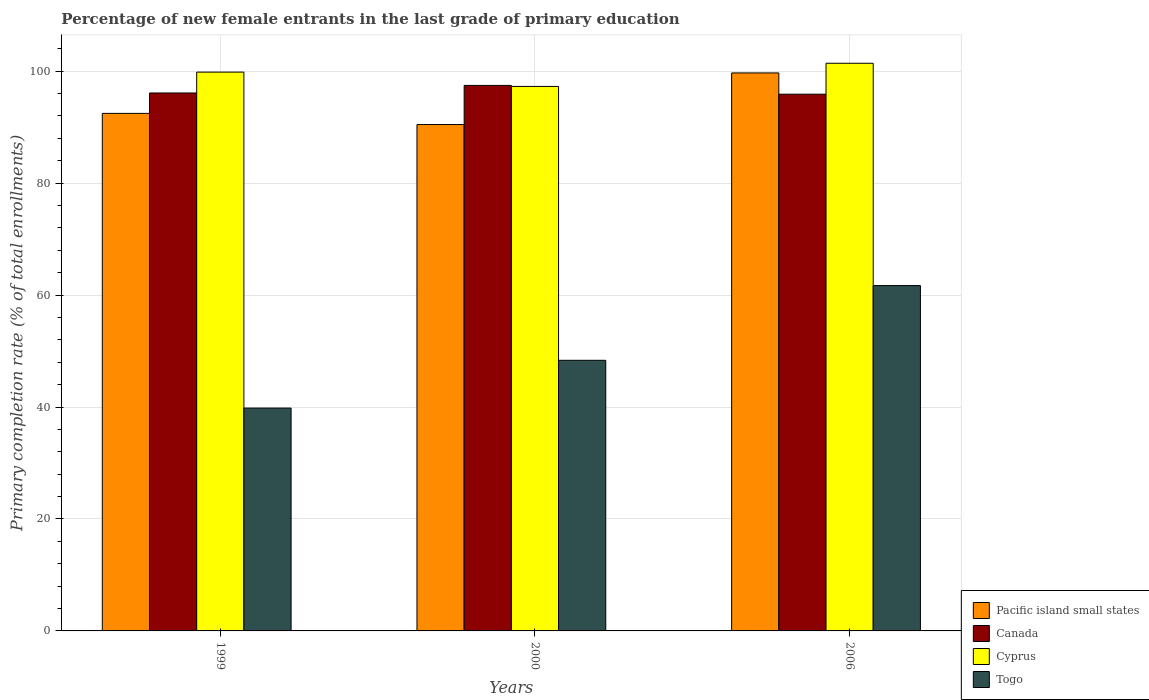How many groups of bars are there?
Offer a very short reply. 3. Are the number of bars per tick equal to the number of legend labels?
Offer a terse response. Yes. What is the percentage of new female entrants in Togo in 1999?
Your response must be concise. 39.81. Across all years, what is the maximum percentage of new female entrants in Canada?
Your answer should be compact. 97.45. Across all years, what is the minimum percentage of new female entrants in Cyprus?
Your response must be concise. 97.27. What is the total percentage of new female entrants in Canada in the graph?
Keep it short and to the point. 289.44. What is the difference between the percentage of new female entrants in Canada in 1999 and that in 2006?
Offer a terse response. 0.22. What is the difference between the percentage of new female entrants in Canada in 2000 and the percentage of new female entrants in Togo in 1999?
Offer a terse response. 57.64. What is the average percentage of new female entrants in Canada per year?
Ensure brevity in your answer.  96.48. In the year 1999, what is the difference between the percentage of new female entrants in Cyprus and percentage of new female entrants in Togo?
Give a very brief answer. 60.02. What is the ratio of the percentage of new female entrants in Canada in 1999 to that in 2006?
Keep it short and to the point. 1. Is the percentage of new female entrants in Cyprus in 2000 less than that in 2006?
Make the answer very short. Yes. Is the difference between the percentage of new female entrants in Cyprus in 1999 and 2006 greater than the difference between the percentage of new female entrants in Togo in 1999 and 2006?
Your answer should be compact. Yes. What is the difference between the highest and the second highest percentage of new female entrants in Canada?
Offer a very short reply. 1.35. What is the difference between the highest and the lowest percentage of new female entrants in Togo?
Offer a terse response. 21.88. Is the sum of the percentage of new female entrants in Pacific island small states in 1999 and 2006 greater than the maximum percentage of new female entrants in Togo across all years?
Provide a short and direct response. Yes. What does the 4th bar from the left in 1999 represents?
Ensure brevity in your answer.  Togo. What does the 4th bar from the right in 1999 represents?
Offer a very short reply. Pacific island small states. Is it the case that in every year, the sum of the percentage of new female entrants in Togo and percentage of new female entrants in Canada is greater than the percentage of new female entrants in Pacific island small states?
Your answer should be very brief. Yes. How many years are there in the graph?
Ensure brevity in your answer.  3. Does the graph contain grids?
Your response must be concise. Yes. What is the title of the graph?
Keep it short and to the point. Percentage of new female entrants in the last grade of primary education. What is the label or title of the Y-axis?
Offer a terse response. Primary completion rate (% of total enrollments). What is the Primary completion rate (% of total enrollments) of Pacific island small states in 1999?
Your response must be concise. 92.46. What is the Primary completion rate (% of total enrollments) in Canada in 1999?
Provide a succinct answer. 96.1. What is the Primary completion rate (% of total enrollments) of Cyprus in 1999?
Ensure brevity in your answer.  99.83. What is the Primary completion rate (% of total enrollments) of Togo in 1999?
Keep it short and to the point. 39.81. What is the Primary completion rate (% of total enrollments) of Pacific island small states in 2000?
Make the answer very short. 90.46. What is the Primary completion rate (% of total enrollments) in Canada in 2000?
Provide a short and direct response. 97.45. What is the Primary completion rate (% of total enrollments) in Cyprus in 2000?
Ensure brevity in your answer.  97.27. What is the Primary completion rate (% of total enrollments) in Togo in 2000?
Your answer should be compact. 48.34. What is the Primary completion rate (% of total enrollments) of Pacific island small states in 2006?
Keep it short and to the point. 99.68. What is the Primary completion rate (% of total enrollments) of Canada in 2006?
Offer a very short reply. 95.89. What is the Primary completion rate (% of total enrollments) in Cyprus in 2006?
Your answer should be very brief. 101.41. What is the Primary completion rate (% of total enrollments) of Togo in 2006?
Keep it short and to the point. 61.7. Across all years, what is the maximum Primary completion rate (% of total enrollments) in Pacific island small states?
Your answer should be compact. 99.68. Across all years, what is the maximum Primary completion rate (% of total enrollments) in Canada?
Keep it short and to the point. 97.45. Across all years, what is the maximum Primary completion rate (% of total enrollments) in Cyprus?
Provide a succinct answer. 101.41. Across all years, what is the maximum Primary completion rate (% of total enrollments) in Togo?
Offer a terse response. 61.7. Across all years, what is the minimum Primary completion rate (% of total enrollments) in Pacific island small states?
Provide a short and direct response. 90.46. Across all years, what is the minimum Primary completion rate (% of total enrollments) in Canada?
Your response must be concise. 95.89. Across all years, what is the minimum Primary completion rate (% of total enrollments) in Cyprus?
Ensure brevity in your answer.  97.27. Across all years, what is the minimum Primary completion rate (% of total enrollments) in Togo?
Provide a short and direct response. 39.81. What is the total Primary completion rate (% of total enrollments) in Pacific island small states in the graph?
Provide a succinct answer. 282.6. What is the total Primary completion rate (% of total enrollments) of Canada in the graph?
Your response must be concise. 289.44. What is the total Primary completion rate (% of total enrollments) of Cyprus in the graph?
Give a very brief answer. 298.51. What is the total Primary completion rate (% of total enrollments) in Togo in the graph?
Offer a very short reply. 149.85. What is the difference between the Primary completion rate (% of total enrollments) of Pacific island small states in 1999 and that in 2000?
Ensure brevity in your answer.  2. What is the difference between the Primary completion rate (% of total enrollments) in Canada in 1999 and that in 2000?
Your response must be concise. -1.35. What is the difference between the Primary completion rate (% of total enrollments) of Cyprus in 1999 and that in 2000?
Your response must be concise. 2.55. What is the difference between the Primary completion rate (% of total enrollments) of Togo in 1999 and that in 2000?
Your response must be concise. -8.53. What is the difference between the Primary completion rate (% of total enrollments) in Pacific island small states in 1999 and that in 2006?
Provide a succinct answer. -7.23. What is the difference between the Primary completion rate (% of total enrollments) in Canada in 1999 and that in 2006?
Make the answer very short. 0.22. What is the difference between the Primary completion rate (% of total enrollments) of Cyprus in 1999 and that in 2006?
Provide a succinct answer. -1.58. What is the difference between the Primary completion rate (% of total enrollments) of Togo in 1999 and that in 2006?
Offer a very short reply. -21.88. What is the difference between the Primary completion rate (% of total enrollments) of Pacific island small states in 2000 and that in 2006?
Your answer should be very brief. -9.22. What is the difference between the Primary completion rate (% of total enrollments) of Canada in 2000 and that in 2006?
Your answer should be very brief. 1.57. What is the difference between the Primary completion rate (% of total enrollments) of Cyprus in 2000 and that in 2006?
Give a very brief answer. -4.14. What is the difference between the Primary completion rate (% of total enrollments) in Togo in 2000 and that in 2006?
Provide a short and direct response. -13.35. What is the difference between the Primary completion rate (% of total enrollments) of Pacific island small states in 1999 and the Primary completion rate (% of total enrollments) of Canada in 2000?
Keep it short and to the point. -5. What is the difference between the Primary completion rate (% of total enrollments) in Pacific island small states in 1999 and the Primary completion rate (% of total enrollments) in Cyprus in 2000?
Your answer should be very brief. -4.82. What is the difference between the Primary completion rate (% of total enrollments) in Pacific island small states in 1999 and the Primary completion rate (% of total enrollments) in Togo in 2000?
Make the answer very short. 44.11. What is the difference between the Primary completion rate (% of total enrollments) of Canada in 1999 and the Primary completion rate (% of total enrollments) of Cyprus in 2000?
Your response must be concise. -1.17. What is the difference between the Primary completion rate (% of total enrollments) of Canada in 1999 and the Primary completion rate (% of total enrollments) of Togo in 2000?
Your response must be concise. 47.76. What is the difference between the Primary completion rate (% of total enrollments) in Cyprus in 1999 and the Primary completion rate (% of total enrollments) in Togo in 2000?
Make the answer very short. 51.48. What is the difference between the Primary completion rate (% of total enrollments) of Pacific island small states in 1999 and the Primary completion rate (% of total enrollments) of Canada in 2006?
Offer a very short reply. -3.43. What is the difference between the Primary completion rate (% of total enrollments) in Pacific island small states in 1999 and the Primary completion rate (% of total enrollments) in Cyprus in 2006?
Offer a terse response. -8.96. What is the difference between the Primary completion rate (% of total enrollments) in Pacific island small states in 1999 and the Primary completion rate (% of total enrollments) in Togo in 2006?
Give a very brief answer. 30.76. What is the difference between the Primary completion rate (% of total enrollments) of Canada in 1999 and the Primary completion rate (% of total enrollments) of Cyprus in 2006?
Provide a succinct answer. -5.31. What is the difference between the Primary completion rate (% of total enrollments) in Canada in 1999 and the Primary completion rate (% of total enrollments) in Togo in 2006?
Your answer should be compact. 34.41. What is the difference between the Primary completion rate (% of total enrollments) of Cyprus in 1999 and the Primary completion rate (% of total enrollments) of Togo in 2006?
Offer a terse response. 38.13. What is the difference between the Primary completion rate (% of total enrollments) of Pacific island small states in 2000 and the Primary completion rate (% of total enrollments) of Canada in 2006?
Keep it short and to the point. -5.43. What is the difference between the Primary completion rate (% of total enrollments) of Pacific island small states in 2000 and the Primary completion rate (% of total enrollments) of Cyprus in 2006?
Provide a short and direct response. -10.95. What is the difference between the Primary completion rate (% of total enrollments) of Pacific island small states in 2000 and the Primary completion rate (% of total enrollments) of Togo in 2006?
Give a very brief answer. 28.76. What is the difference between the Primary completion rate (% of total enrollments) of Canada in 2000 and the Primary completion rate (% of total enrollments) of Cyprus in 2006?
Offer a very short reply. -3.96. What is the difference between the Primary completion rate (% of total enrollments) in Canada in 2000 and the Primary completion rate (% of total enrollments) in Togo in 2006?
Offer a terse response. 35.76. What is the difference between the Primary completion rate (% of total enrollments) in Cyprus in 2000 and the Primary completion rate (% of total enrollments) in Togo in 2006?
Keep it short and to the point. 35.58. What is the average Primary completion rate (% of total enrollments) of Pacific island small states per year?
Your answer should be very brief. 94.2. What is the average Primary completion rate (% of total enrollments) of Canada per year?
Offer a terse response. 96.48. What is the average Primary completion rate (% of total enrollments) in Cyprus per year?
Keep it short and to the point. 99.5. What is the average Primary completion rate (% of total enrollments) in Togo per year?
Your response must be concise. 49.95. In the year 1999, what is the difference between the Primary completion rate (% of total enrollments) in Pacific island small states and Primary completion rate (% of total enrollments) in Canada?
Your response must be concise. -3.65. In the year 1999, what is the difference between the Primary completion rate (% of total enrollments) of Pacific island small states and Primary completion rate (% of total enrollments) of Cyprus?
Keep it short and to the point. -7.37. In the year 1999, what is the difference between the Primary completion rate (% of total enrollments) of Pacific island small states and Primary completion rate (% of total enrollments) of Togo?
Your answer should be compact. 52.64. In the year 1999, what is the difference between the Primary completion rate (% of total enrollments) of Canada and Primary completion rate (% of total enrollments) of Cyprus?
Your response must be concise. -3.73. In the year 1999, what is the difference between the Primary completion rate (% of total enrollments) in Canada and Primary completion rate (% of total enrollments) in Togo?
Your response must be concise. 56.29. In the year 1999, what is the difference between the Primary completion rate (% of total enrollments) of Cyprus and Primary completion rate (% of total enrollments) of Togo?
Your answer should be compact. 60.02. In the year 2000, what is the difference between the Primary completion rate (% of total enrollments) of Pacific island small states and Primary completion rate (% of total enrollments) of Canada?
Provide a short and direct response. -6.99. In the year 2000, what is the difference between the Primary completion rate (% of total enrollments) of Pacific island small states and Primary completion rate (% of total enrollments) of Cyprus?
Provide a short and direct response. -6.81. In the year 2000, what is the difference between the Primary completion rate (% of total enrollments) of Pacific island small states and Primary completion rate (% of total enrollments) of Togo?
Offer a terse response. 42.12. In the year 2000, what is the difference between the Primary completion rate (% of total enrollments) in Canada and Primary completion rate (% of total enrollments) in Cyprus?
Offer a very short reply. 0.18. In the year 2000, what is the difference between the Primary completion rate (% of total enrollments) of Canada and Primary completion rate (% of total enrollments) of Togo?
Your response must be concise. 49.11. In the year 2000, what is the difference between the Primary completion rate (% of total enrollments) of Cyprus and Primary completion rate (% of total enrollments) of Togo?
Offer a terse response. 48.93. In the year 2006, what is the difference between the Primary completion rate (% of total enrollments) of Pacific island small states and Primary completion rate (% of total enrollments) of Canada?
Offer a terse response. 3.8. In the year 2006, what is the difference between the Primary completion rate (% of total enrollments) in Pacific island small states and Primary completion rate (% of total enrollments) in Cyprus?
Your answer should be very brief. -1.73. In the year 2006, what is the difference between the Primary completion rate (% of total enrollments) in Pacific island small states and Primary completion rate (% of total enrollments) in Togo?
Your answer should be very brief. 37.99. In the year 2006, what is the difference between the Primary completion rate (% of total enrollments) of Canada and Primary completion rate (% of total enrollments) of Cyprus?
Your answer should be very brief. -5.53. In the year 2006, what is the difference between the Primary completion rate (% of total enrollments) of Canada and Primary completion rate (% of total enrollments) of Togo?
Ensure brevity in your answer.  34.19. In the year 2006, what is the difference between the Primary completion rate (% of total enrollments) in Cyprus and Primary completion rate (% of total enrollments) in Togo?
Offer a terse response. 39.71. What is the ratio of the Primary completion rate (% of total enrollments) in Pacific island small states in 1999 to that in 2000?
Offer a terse response. 1.02. What is the ratio of the Primary completion rate (% of total enrollments) in Canada in 1999 to that in 2000?
Offer a very short reply. 0.99. What is the ratio of the Primary completion rate (% of total enrollments) of Cyprus in 1999 to that in 2000?
Offer a terse response. 1.03. What is the ratio of the Primary completion rate (% of total enrollments) of Togo in 1999 to that in 2000?
Your response must be concise. 0.82. What is the ratio of the Primary completion rate (% of total enrollments) in Pacific island small states in 1999 to that in 2006?
Keep it short and to the point. 0.93. What is the ratio of the Primary completion rate (% of total enrollments) in Cyprus in 1999 to that in 2006?
Your answer should be very brief. 0.98. What is the ratio of the Primary completion rate (% of total enrollments) of Togo in 1999 to that in 2006?
Your answer should be compact. 0.65. What is the ratio of the Primary completion rate (% of total enrollments) in Pacific island small states in 2000 to that in 2006?
Keep it short and to the point. 0.91. What is the ratio of the Primary completion rate (% of total enrollments) in Canada in 2000 to that in 2006?
Make the answer very short. 1.02. What is the ratio of the Primary completion rate (% of total enrollments) in Cyprus in 2000 to that in 2006?
Offer a very short reply. 0.96. What is the ratio of the Primary completion rate (% of total enrollments) of Togo in 2000 to that in 2006?
Your answer should be compact. 0.78. What is the difference between the highest and the second highest Primary completion rate (% of total enrollments) in Pacific island small states?
Your response must be concise. 7.23. What is the difference between the highest and the second highest Primary completion rate (% of total enrollments) of Canada?
Keep it short and to the point. 1.35. What is the difference between the highest and the second highest Primary completion rate (% of total enrollments) in Cyprus?
Ensure brevity in your answer.  1.58. What is the difference between the highest and the second highest Primary completion rate (% of total enrollments) in Togo?
Your answer should be compact. 13.35. What is the difference between the highest and the lowest Primary completion rate (% of total enrollments) of Pacific island small states?
Your answer should be compact. 9.22. What is the difference between the highest and the lowest Primary completion rate (% of total enrollments) of Canada?
Make the answer very short. 1.57. What is the difference between the highest and the lowest Primary completion rate (% of total enrollments) of Cyprus?
Your answer should be compact. 4.14. What is the difference between the highest and the lowest Primary completion rate (% of total enrollments) of Togo?
Keep it short and to the point. 21.88. 